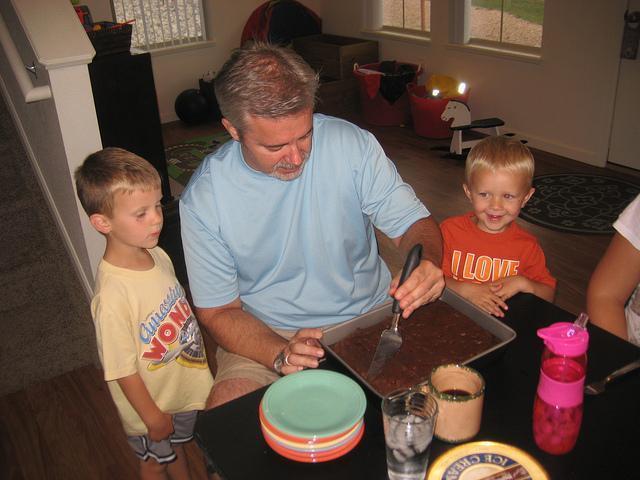How many people are there?
Give a very brief answer. 4. How many dining tables are there?
Give a very brief answer. 2. How many cups are there?
Give a very brief answer. 3. 